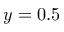Convert formula to latex. <formula><loc_0><loc_0><loc_500><loc_500>y = 0 . 5</formula> 